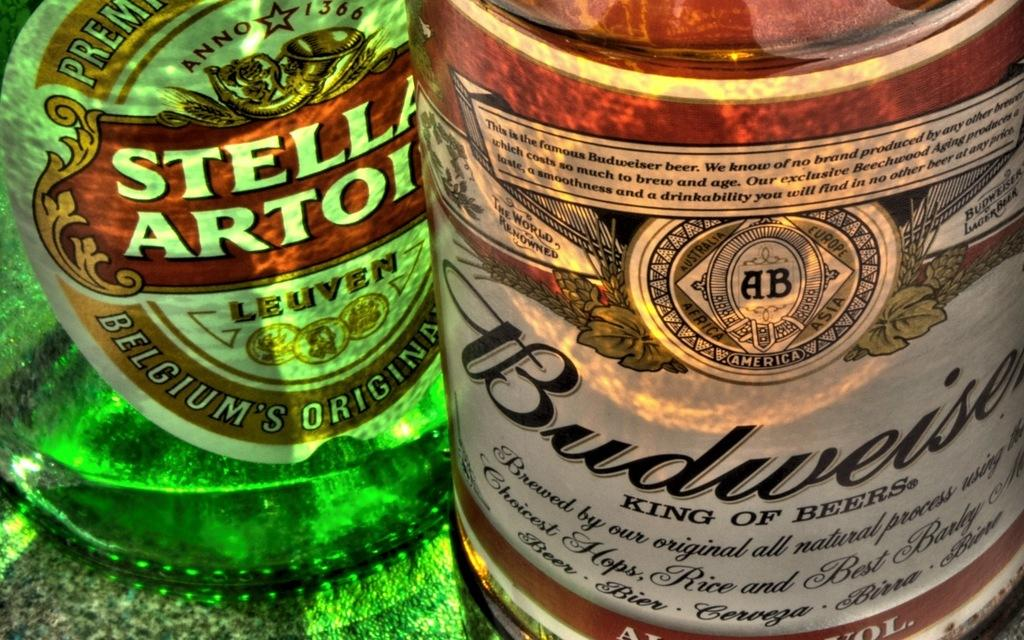<image>
Offer a succinct explanation of the picture presented. A bottle of Stella Artois is next to a bottle of Budweiser. 